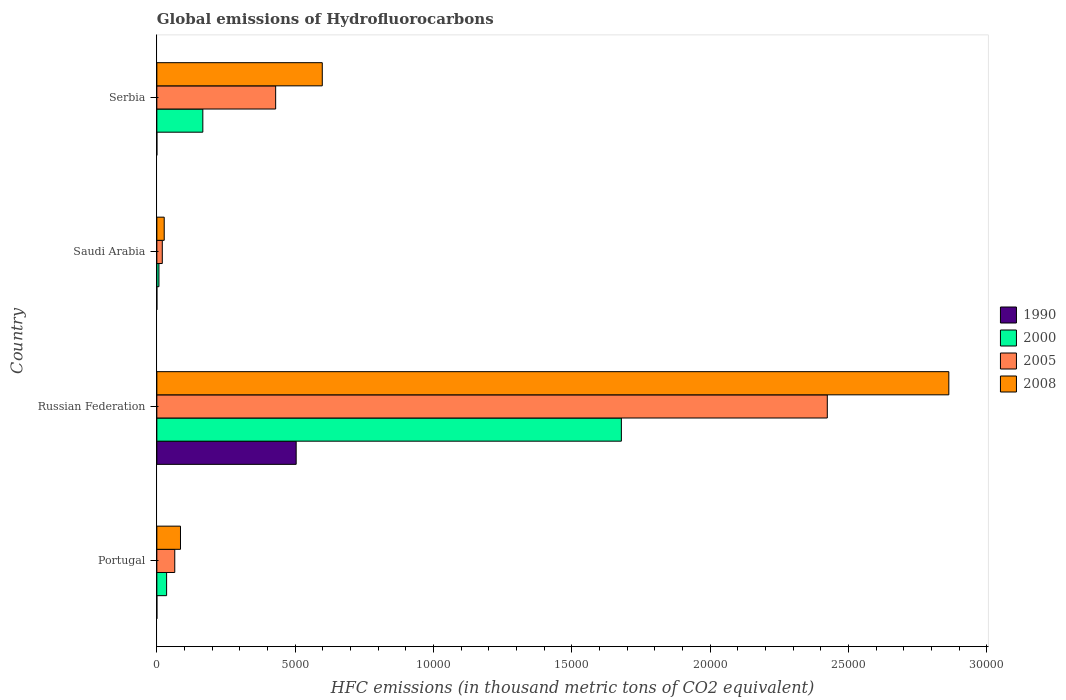Are the number of bars per tick equal to the number of legend labels?
Make the answer very short. Yes. What is the label of the 4th group of bars from the top?
Your answer should be very brief. Portugal. In how many cases, is the number of bars for a given country not equal to the number of legend labels?
Ensure brevity in your answer.  0. What is the global emissions of Hydrofluorocarbons in 2008 in Serbia?
Your answer should be very brief. 5979. Across all countries, what is the maximum global emissions of Hydrofluorocarbons in 1990?
Offer a very short reply. 5035.6. In which country was the global emissions of Hydrofluorocarbons in 2008 maximum?
Your answer should be very brief. Russian Federation. In which country was the global emissions of Hydrofluorocarbons in 2008 minimum?
Ensure brevity in your answer.  Saudi Arabia. What is the total global emissions of Hydrofluorocarbons in 2000 in the graph?
Keep it short and to the point. 1.89e+04. What is the difference between the global emissions of Hydrofluorocarbons in 1990 in Portugal and that in Russian Federation?
Your answer should be compact. -5035.4. What is the difference between the global emissions of Hydrofluorocarbons in 2005 in Russian Federation and the global emissions of Hydrofluorocarbons in 2008 in Portugal?
Provide a succinct answer. 2.34e+04. What is the average global emissions of Hydrofluorocarbons in 1990 per country?
Your answer should be compact. 1259.1. What is the difference between the global emissions of Hydrofluorocarbons in 2008 and global emissions of Hydrofluorocarbons in 1990 in Saudi Arabia?
Your response must be concise. 266.4. In how many countries, is the global emissions of Hydrofluorocarbons in 2000 greater than 4000 thousand metric tons?
Your answer should be compact. 1. What is the ratio of the global emissions of Hydrofluorocarbons in 2000 in Russian Federation to that in Serbia?
Offer a very short reply. 10.1. Is the global emissions of Hydrofluorocarbons in 2000 in Portugal less than that in Saudi Arabia?
Offer a terse response. No. What is the difference between the highest and the second highest global emissions of Hydrofluorocarbons in 2008?
Your response must be concise. 2.26e+04. What is the difference between the highest and the lowest global emissions of Hydrofluorocarbons in 2005?
Provide a succinct answer. 2.40e+04. In how many countries, is the global emissions of Hydrofluorocarbons in 1990 greater than the average global emissions of Hydrofluorocarbons in 1990 taken over all countries?
Provide a succinct answer. 1. What does the 3rd bar from the top in Russian Federation represents?
Your answer should be very brief. 2000. How many bars are there?
Your response must be concise. 16. Are all the bars in the graph horizontal?
Keep it short and to the point. Yes. Are the values on the major ticks of X-axis written in scientific E-notation?
Offer a very short reply. No. Does the graph contain grids?
Your answer should be compact. No. How many legend labels are there?
Offer a very short reply. 4. How are the legend labels stacked?
Ensure brevity in your answer.  Vertical. What is the title of the graph?
Your answer should be compact. Global emissions of Hydrofluorocarbons. What is the label or title of the X-axis?
Your response must be concise. HFC emissions (in thousand metric tons of CO2 equivalent). What is the label or title of the Y-axis?
Give a very brief answer. Country. What is the HFC emissions (in thousand metric tons of CO2 equivalent) of 2000 in Portugal?
Ensure brevity in your answer.  352.7. What is the HFC emissions (in thousand metric tons of CO2 equivalent) in 2005 in Portugal?
Your response must be concise. 647.7. What is the HFC emissions (in thousand metric tons of CO2 equivalent) of 2008 in Portugal?
Offer a terse response. 854.4. What is the HFC emissions (in thousand metric tons of CO2 equivalent) of 1990 in Russian Federation?
Offer a terse response. 5035.6. What is the HFC emissions (in thousand metric tons of CO2 equivalent) in 2000 in Russian Federation?
Your response must be concise. 1.68e+04. What is the HFC emissions (in thousand metric tons of CO2 equivalent) in 2005 in Russian Federation?
Offer a terse response. 2.42e+04. What is the HFC emissions (in thousand metric tons of CO2 equivalent) of 2008 in Russian Federation?
Offer a very short reply. 2.86e+04. What is the HFC emissions (in thousand metric tons of CO2 equivalent) of 2000 in Saudi Arabia?
Offer a terse response. 75.5. What is the HFC emissions (in thousand metric tons of CO2 equivalent) in 2005 in Saudi Arabia?
Make the answer very short. 196.9. What is the HFC emissions (in thousand metric tons of CO2 equivalent) in 2008 in Saudi Arabia?
Your answer should be very brief. 266.5. What is the HFC emissions (in thousand metric tons of CO2 equivalent) of 1990 in Serbia?
Provide a succinct answer. 0.5. What is the HFC emissions (in thousand metric tons of CO2 equivalent) of 2000 in Serbia?
Provide a short and direct response. 1662. What is the HFC emissions (in thousand metric tons of CO2 equivalent) of 2005 in Serbia?
Provide a succinct answer. 4293.8. What is the HFC emissions (in thousand metric tons of CO2 equivalent) in 2008 in Serbia?
Provide a short and direct response. 5979. Across all countries, what is the maximum HFC emissions (in thousand metric tons of CO2 equivalent) in 1990?
Your answer should be compact. 5035.6. Across all countries, what is the maximum HFC emissions (in thousand metric tons of CO2 equivalent) of 2000?
Ensure brevity in your answer.  1.68e+04. Across all countries, what is the maximum HFC emissions (in thousand metric tons of CO2 equivalent) in 2005?
Keep it short and to the point. 2.42e+04. Across all countries, what is the maximum HFC emissions (in thousand metric tons of CO2 equivalent) in 2008?
Provide a succinct answer. 2.86e+04. Across all countries, what is the minimum HFC emissions (in thousand metric tons of CO2 equivalent) in 2000?
Your response must be concise. 75.5. Across all countries, what is the minimum HFC emissions (in thousand metric tons of CO2 equivalent) in 2005?
Provide a succinct answer. 196.9. Across all countries, what is the minimum HFC emissions (in thousand metric tons of CO2 equivalent) in 2008?
Make the answer very short. 266.5. What is the total HFC emissions (in thousand metric tons of CO2 equivalent) in 1990 in the graph?
Provide a short and direct response. 5036.4. What is the total HFC emissions (in thousand metric tons of CO2 equivalent) of 2000 in the graph?
Ensure brevity in your answer.  1.89e+04. What is the total HFC emissions (in thousand metric tons of CO2 equivalent) in 2005 in the graph?
Give a very brief answer. 2.94e+04. What is the total HFC emissions (in thousand metric tons of CO2 equivalent) in 2008 in the graph?
Offer a terse response. 3.57e+04. What is the difference between the HFC emissions (in thousand metric tons of CO2 equivalent) in 1990 in Portugal and that in Russian Federation?
Provide a short and direct response. -5035.4. What is the difference between the HFC emissions (in thousand metric tons of CO2 equivalent) of 2000 in Portugal and that in Russian Federation?
Provide a succinct answer. -1.64e+04. What is the difference between the HFC emissions (in thousand metric tons of CO2 equivalent) of 2005 in Portugal and that in Russian Federation?
Keep it short and to the point. -2.36e+04. What is the difference between the HFC emissions (in thousand metric tons of CO2 equivalent) in 2008 in Portugal and that in Russian Federation?
Your answer should be very brief. -2.78e+04. What is the difference between the HFC emissions (in thousand metric tons of CO2 equivalent) in 2000 in Portugal and that in Saudi Arabia?
Keep it short and to the point. 277.2. What is the difference between the HFC emissions (in thousand metric tons of CO2 equivalent) in 2005 in Portugal and that in Saudi Arabia?
Give a very brief answer. 450.8. What is the difference between the HFC emissions (in thousand metric tons of CO2 equivalent) in 2008 in Portugal and that in Saudi Arabia?
Keep it short and to the point. 587.9. What is the difference between the HFC emissions (in thousand metric tons of CO2 equivalent) in 2000 in Portugal and that in Serbia?
Make the answer very short. -1309.3. What is the difference between the HFC emissions (in thousand metric tons of CO2 equivalent) in 2005 in Portugal and that in Serbia?
Ensure brevity in your answer.  -3646.1. What is the difference between the HFC emissions (in thousand metric tons of CO2 equivalent) of 2008 in Portugal and that in Serbia?
Provide a short and direct response. -5124.6. What is the difference between the HFC emissions (in thousand metric tons of CO2 equivalent) of 1990 in Russian Federation and that in Saudi Arabia?
Your answer should be compact. 5035.5. What is the difference between the HFC emissions (in thousand metric tons of CO2 equivalent) of 2000 in Russian Federation and that in Saudi Arabia?
Give a very brief answer. 1.67e+04. What is the difference between the HFC emissions (in thousand metric tons of CO2 equivalent) of 2005 in Russian Federation and that in Saudi Arabia?
Give a very brief answer. 2.40e+04. What is the difference between the HFC emissions (in thousand metric tons of CO2 equivalent) of 2008 in Russian Federation and that in Saudi Arabia?
Provide a short and direct response. 2.84e+04. What is the difference between the HFC emissions (in thousand metric tons of CO2 equivalent) of 1990 in Russian Federation and that in Serbia?
Ensure brevity in your answer.  5035.1. What is the difference between the HFC emissions (in thousand metric tons of CO2 equivalent) of 2000 in Russian Federation and that in Serbia?
Offer a terse response. 1.51e+04. What is the difference between the HFC emissions (in thousand metric tons of CO2 equivalent) in 2005 in Russian Federation and that in Serbia?
Make the answer very short. 1.99e+04. What is the difference between the HFC emissions (in thousand metric tons of CO2 equivalent) in 2008 in Russian Federation and that in Serbia?
Your answer should be compact. 2.26e+04. What is the difference between the HFC emissions (in thousand metric tons of CO2 equivalent) in 1990 in Saudi Arabia and that in Serbia?
Offer a very short reply. -0.4. What is the difference between the HFC emissions (in thousand metric tons of CO2 equivalent) of 2000 in Saudi Arabia and that in Serbia?
Offer a very short reply. -1586.5. What is the difference between the HFC emissions (in thousand metric tons of CO2 equivalent) in 2005 in Saudi Arabia and that in Serbia?
Your answer should be compact. -4096.9. What is the difference between the HFC emissions (in thousand metric tons of CO2 equivalent) in 2008 in Saudi Arabia and that in Serbia?
Keep it short and to the point. -5712.5. What is the difference between the HFC emissions (in thousand metric tons of CO2 equivalent) in 1990 in Portugal and the HFC emissions (in thousand metric tons of CO2 equivalent) in 2000 in Russian Federation?
Offer a very short reply. -1.68e+04. What is the difference between the HFC emissions (in thousand metric tons of CO2 equivalent) of 1990 in Portugal and the HFC emissions (in thousand metric tons of CO2 equivalent) of 2005 in Russian Federation?
Provide a succinct answer. -2.42e+04. What is the difference between the HFC emissions (in thousand metric tons of CO2 equivalent) of 1990 in Portugal and the HFC emissions (in thousand metric tons of CO2 equivalent) of 2008 in Russian Federation?
Your answer should be compact. -2.86e+04. What is the difference between the HFC emissions (in thousand metric tons of CO2 equivalent) of 2000 in Portugal and the HFC emissions (in thousand metric tons of CO2 equivalent) of 2005 in Russian Federation?
Offer a terse response. -2.39e+04. What is the difference between the HFC emissions (in thousand metric tons of CO2 equivalent) in 2000 in Portugal and the HFC emissions (in thousand metric tons of CO2 equivalent) in 2008 in Russian Federation?
Your answer should be very brief. -2.83e+04. What is the difference between the HFC emissions (in thousand metric tons of CO2 equivalent) in 2005 in Portugal and the HFC emissions (in thousand metric tons of CO2 equivalent) in 2008 in Russian Federation?
Ensure brevity in your answer.  -2.80e+04. What is the difference between the HFC emissions (in thousand metric tons of CO2 equivalent) of 1990 in Portugal and the HFC emissions (in thousand metric tons of CO2 equivalent) of 2000 in Saudi Arabia?
Give a very brief answer. -75.3. What is the difference between the HFC emissions (in thousand metric tons of CO2 equivalent) of 1990 in Portugal and the HFC emissions (in thousand metric tons of CO2 equivalent) of 2005 in Saudi Arabia?
Provide a succinct answer. -196.7. What is the difference between the HFC emissions (in thousand metric tons of CO2 equivalent) of 1990 in Portugal and the HFC emissions (in thousand metric tons of CO2 equivalent) of 2008 in Saudi Arabia?
Offer a very short reply. -266.3. What is the difference between the HFC emissions (in thousand metric tons of CO2 equivalent) in 2000 in Portugal and the HFC emissions (in thousand metric tons of CO2 equivalent) in 2005 in Saudi Arabia?
Provide a succinct answer. 155.8. What is the difference between the HFC emissions (in thousand metric tons of CO2 equivalent) in 2000 in Portugal and the HFC emissions (in thousand metric tons of CO2 equivalent) in 2008 in Saudi Arabia?
Ensure brevity in your answer.  86.2. What is the difference between the HFC emissions (in thousand metric tons of CO2 equivalent) of 2005 in Portugal and the HFC emissions (in thousand metric tons of CO2 equivalent) of 2008 in Saudi Arabia?
Your answer should be compact. 381.2. What is the difference between the HFC emissions (in thousand metric tons of CO2 equivalent) of 1990 in Portugal and the HFC emissions (in thousand metric tons of CO2 equivalent) of 2000 in Serbia?
Your answer should be compact. -1661.8. What is the difference between the HFC emissions (in thousand metric tons of CO2 equivalent) of 1990 in Portugal and the HFC emissions (in thousand metric tons of CO2 equivalent) of 2005 in Serbia?
Keep it short and to the point. -4293.6. What is the difference between the HFC emissions (in thousand metric tons of CO2 equivalent) of 1990 in Portugal and the HFC emissions (in thousand metric tons of CO2 equivalent) of 2008 in Serbia?
Your answer should be very brief. -5978.8. What is the difference between the HFC emissions (in thousand metric tons of CO2 equivalent) of 2000 in Portugal and the HFC emissions (in thousand metric tons of CO2 equivalent) of 2005 in Serbia?
Your response must be concise. -3941.1. What is the difference between the HFC emissions (in thousand metric tons of CO2 equivalent) in 2000 in Portugal and the HFC emissions (in thousand metric tons of CO2 equivalent) in 2008 in Serbia?
Give a very brief answer. -5626.3. What is the difference between the HFC emissions (in thousand metric tons of CO2 equivalent) of 2005 in Portugal and the HFC emissions (in thousand metric tons of CO2 equivalent) of 2008 in Serbia?
Ensure brevity in your answer.  -5331.3. What is the difference between the HFC emissions (in thousand metric tons of CO2 equivalent) of 1990 in Russian Federation and the HFC emissions (in thousand metric tons of CO2 equivalent) of 2000 in Saudi Arabia?
Your response must be concise. 4960.1. What is the difference between the HFC emissions (in thousand metric tons of CO2 equivalent) of 1990 in Russian Federation and the HFC emissions (in thousand metric tons of CO2 equivalent) of 2005 in Saudi Arabia?
Your response must be concise. 4838.7. What is the difference between the HFC emissions (in thousand metric tons of CO2 equivalent) of 1990 in Russian Federation and the HFC emissions (in thousand metric tons of CO2 equivalent) of 2008 in Saudi Arabia?
Give a very brief answer. 4769.1. What is the difference between the HFC emissions (in thousand metric tons of CO2 equivalent) in 2000 in Russian Federation and the HFC emissions (in thousand metric tons of CO2 equivalent) in 2005 in Saudi Arabia?
Your answer should be very brief. 1.66e+04. What is the difference between the HFC emissions (in thousand metric tons of CO2 equivalent) in 2000 in Russian Federation and the HFC emissions (in thousand metric tons of CO2 equivalent) in 2008 in Saudi Arabia?
Offer a terse response. 1.65e+04. What is the difference between the HFC emissions (in thousand metric tons of CO2 equivalent) in 2005 in Russian Federation and the HFC emissions (in thousand metric tons of CO2 equivalent) in 2008 in Saudi Arabia?
Your response must be concise. 2.40e+04. What is the difference between the HFC emissions (in thousand metric tons of CO2 equivalent) in 1990 in Russian Federation and the HFC emissions (in thousand metric tons of CO2 equivalent) in 2000 in Serbia?
Your response must be concise. 3373.6. What is the difference between the HFC emissions (in thousand metric tons of CO2 equivalent) in 1990 in Russian Federation and the HFC emissions (in thousand metric tons of CO2 equivalent) in 2005 in Serbia?
Offer a terse response. 741.8. What is the difference between the HFC emissions (in thousand metric tons of CO2 equivalent) of 1990 in Russian Federation and the HFC emissions (in thousand metric tons of CO2 equivalent) of 2008 in Serbia?
Give a very brief answer. -943.4. What is the difference between the HFC emissions (in thousand metric tons of CO2 equivalent) of 2000 in Russian Federation and the HFC emissions (in thousand metric tons of CO2 equivalent) of 2005 in Serbia?
Offer a very short reply. 1.25e+04. What is the difference between the HFC emissions (in thousand metric tons of CO2 equivalent) of 2000 in Russian Federation and the HFC emissions (in thousand metric tons of CO2 equivalent) of 2008 in Serbia?
Keep it short and to the point. 1.08e+04. What is the difference between the HFC emissions (in thousand metric tons of CO2 equivalent) of 2005 in Russian Federation and the HFC emissions (in thousand metric tons of CO2 equivalent) of 2008 in Serbia?
Offer a very short reply. 1.83e+04. What is the difference between the HFC emissions (in thousand metric tons of CO2 equivalent) of 1990 in Saudi Arabia and the HFC emissions (in thousand metric tons of CO2 equivalent) of 2000 in Serbia?
Give a very brief answer. -1661.9. What is the difference between the HFC emissions (in thousand metric tons of CO2 equivalent) of 1990 in Saudi Arabia and the HFC emissions (in thousand metric tons of CO2 equivalent) of 2005 in Serbia?
Keep it short and to the point. -4293.7. What is the difference between the HFC emissions (in thousand metric tons of CO2 equivalent) of 1990 in Saudi Arabia and the HFC emissions (in thousand metric tons of CO2 equivalent) of 2008 in Serbia?
Make the answer very short. -5978.9. What is the difference between the HFC emissions (in thousand metric tons of CO2 equivalent) in 2000 in Saudi Arabia and the HFC emissions (in thousand metric tons of CO2 equivalent) in 2005 in Serbia?
Your answer should be very brief. -4218.3. What is the difference between the HFC emissions (in thousand metric tons of CO2 equivalent) of 2000 in Saudi Arabia and the HFC emissions (in thousand metric tons of CO2 equivalent) of 2008 in Serbia?
Give a very brief answer. -5903.5. What is the difference between the HFC emissions (in thousand metric tons of CO2 equivalent) of 2005 in Saudi Arabia and the HFC emissions (in thousand metric tons of CO2 equivalent) of 2008 in Serbia?
Your answer should be very brief. -5782.1. What is the average HFC emissions (in thousand metric tons of CO2 equivalent) in 1990 per country?
Give a very brief answer. 1259.1. What is the average HFC emissions (in thousand metric tons of CO2 equivalent) of 2000 per country?
Make the answer very short. 4719.73. What is the average HFC emissions (in thousand metric tons of CO2 equivalent) in 2005 per country?
Ensure brevity in your answer.  7342.43. What is the average HFC emissions (in thousand metric tons of CO2 equivalent) in 2008 per country?
Offer a terse response. 8930.85. What is the difference between the HFC emissions (in thousand metric tons of CO2 equivalent) of 1990 and HFC emissions (in thousand metric tons of CO2 equivalent) of 2000 in Portugal?
Ensure brevity in your answer.  -352.5. What is the difference between the HFC emissions (in thousand metric tons of CO2 equivalent) in 1990 and HFC emissions (in thousand metric tons of CO2 equivalent) in 2005 in Portugal?
Your answer should be compact. -647.5. What is the difference between the HFC emissions (in thousand metric tons of CO2 equivalent) in 1990 and HFC emissions (in thousand metric tons of CO2 equivalent) in 2008 in Portugal?
Your answer should be very brief. -854.2. What is the difference between the HFC emissions (in thousand metric tons of CO2 equivalent) in 2000 and HFC emissions (in thousand metric tons of CO2 equivalent) in 2005 in Portugal?
Your answer should be compact. -295. What is the difference between the HFC emissions (in thousand metric tons of CO2 equivalent) in 2000 and HFC emissions (in thousand metric tons of CO2 equivalent) in 2008 in Portugal?
Offer a terse response. -501.7. What is the difference between the HFC emissions (in thousand metric tons of CO2 equivalent) of 2005 and HFC emissions (in thousand metric tons of CO2 equivalent) of 2008 in Portugal?
Provide a short and direct response. -206.7. What is the difference between the HFC emissions (in thousand metric tons of CO2 equivalent) in 1990 and HFC emissions (in thousand metric tons of CO2 equivalent) in 2000 in Russian Federation?
Provide a short and direct response. -1.18e+04. What is the difference between the HFC emissions (in thousand metric tons of CO2 equivalent) in 1990 and HFC emissions (in thousand metric tons of CO2 equivalent) in 2005 in Russian Federation?
Make the answer very short. -1.92e+04. What is the difference between the HFC emissions (in thousand metric tons of CO2 equivalent) in 1990 and HFC emissions (in thousand metric tons of CO2 equivalent) in 2008 in Russian Federation?
Give a very brief answer. -2.36e+04. What is the difference between the HFC emissions (in thousand metric tons of CO2 equivalent) of 2000 and HFC emissions (in thousand metric tons of CO2 equivalent) of 2005 in Russian Federation?
Ensure brevity in your answer.  -7442.6. What is the difference between the HFC emissions (in thousand metric tons of CO2 equivalent) in 2000 and HFC emissions (in thousand metric tons of CO2 equivalent) in 2008 in Russian Federation?
Make the answer very short. -1.18e+04. What is the difference between the HFC emissions (in thousand metric tons of CO2 equivalent) of 2005 and HFC emissions (in thousand metric tons of CO2 equivalent) of 2008 in Russian Federation?
Make the answer very short. -4392.2. What is the difference between the HFC emissions (in thousand metric tons of CO2 equivalent) of 1990 and HFC emissions (in thousand metric tons of CO2 equivalent) of 2000 in Saudi Arabia?
Make the answer very short. -75.4. What is the difference between the HFC emissions (in thousand metric tons of CO2 equivalent) in 1990 and HFC emissions (in thousand metric tons of CO2 equivalent) in 2005 in Saudi Arabia?
Your answer should be very brief. -196.8. What is the difference between the HFC emissions (in thousand metric tons of CO2 equivalent) of 1990 and HFC emissions (in thousand metric tons of CO2 equivalent) of 2008 in Saudi Arabia?
Give a very brief answer. -266.4. What is the difference between the HFC emissions (in thousand metric tons of CO2 equivalent) of 2000 and HFC emissions (in thousand metric tons of CO2 equivalent) of 2005 in Saudi Arabia?
Make the answer very short. -121.4. What is the difference between the HFC emissions (in thousand metric tons of CO2 equivalent) in 2000 and HFC emissions (in thousand metric tons of CO2 equivalent) in 2008 in Saudi Arabia?
Make the answer very short. -191. What is the difference between the HFC emissions (in thousand metric tons of CO2 equivalent) of 2005 and HFC emissions (in thousand metric tons of CO2 equivalent) of 2008 in Saudi Arabia?
Provide a succinct answer. -69.6. What is the difference between the HFC emissions (in thousand metric tons of CO2 equivalent) of 1990 and HFC emissions (in thousand metric tons of CO2 equivalent) of 2000 in Serbia?
Provide a short and direct response. -1661.5. What is the difference between the HFC emissions (in thousand metric tons of CO2 equivalent) of 1990 and HFC emissions (in thousand metric tons of CO2 equivalent) of 2005 in Serbia?
Give a very brief answer. -4293.3. What is the difference between the HFC emissions (in thousand metric tons of CO2 equivalent) in 1990 and HFC emissions (in thousand metric tons of CO2 equivalent) in 2008 in Serbia?
Your response must be concise. -5978.5. What is the difference between the HFC emissions (in thousand metric tons of CO2 equivalent) in 2000 and HFC emissions (in thousand metric tons of CO2 equivalent) in 2005 in Serbia?
Provide a succinct answer. -2631.8. What is the difference between the HFC emissions (in thousand metric tons of CO2 equivalent) of 2000 and HFC emissions (in thousand metric tons of CO2 equivalent) of 2008 in Serbia?
Your response must be concise. -4317. What is the difference between the HFC emissions (in thousand metric tons of CO2 equivalent) of 2005 and HFC emissions (in thousand metric tons of CO2 equivalent) of 2008 in Serbia?
Offer a terse response. -1685.2. What is the ratio of the HFC emissions (in thousand metric tons of CO2 equivalent) of 1990 in Portugal to that in Russian Federation?
Your response must be concise. 0. What is the ratio of the HFC emissions (in thousand metric tons of CO2 equivalent) of 2000 in Portugal to that in Russian Federation?
Give a very brief answer. 0.02. What is the ratio of the HFC emissions (in thousand metric tons of CO2 equivalent) of 2005 in Portugal to that in Russian Federation?
Your answer should be compact. 0.03. What is the ratio of the HFC emissions (in thousand metric tons of CO2 equivalent) in 2008 in Portugal to that in Russian Federation?
Provide a short and direct response. 0.03. What is the ratio of the HFC emissions (in thousand metric tons of CO2 equivalent) of 2000 in Portugal to that in Saudi Arabia?
Keep it short and to the point. 4.67. What is the ratio of the HFC emissions (in thousand metric tons of CO2 equivalent) of 2005 in Portugal to that in Saudi Arabia?
Offer a terse response. 3.29. What is the ratio of the HFC emissions (in thousand metric tons of CO2 equivalent) of 2008 in Portugal to that in Saudi Arabia?
Offer a terse response. 3.21. What is the ratio of the HFC emissions (in thousand metric tons of CO2 equivalent) in 1990 in Portugal to that in Serbia?
Your answer should be very brief. 0.4. What is the ratio of the HFC emissions (in thousand metric tons of CO2 equivalent) in 2000 in Portugal to that in Serbia?
Your answer should be compact. 0.21. What is the ratio of the HFC emissions (in thousand metric tons of CO2 equivalent) of 2005 in Portugal to that in Serbia?
Keep it short and to the point. 0.15. What is the ratio of the HFC emissions (in thousand metric tons of CO2 equivalent) in 2008 in Portugal to that in Serbia?
Your answer should be very brief. 0.14. What is the ratio of the HFC emissions (in thousand metric tons of CO2 equivalent) in 1990 in Russian Federation to that in Saudi Arabia?
Provide a short and direct response. 5.04e+04. What is the ratio of the HFC emissions (in thousand metric tons of CO2 equivalent) of 2000 in Russian Federation to that in Saudi Arabia?
Offer a terse response. 222.37. What is the ratio of the HFC emissions (in thousand metric tons of CO2 equivalent) of 2005 in Russian Federation to that in Saudi Arabia?
Your answer should be compact. 123.06. What is the ratio of the HFC emissions (in thousand metric tons of CO2 equivalent) in 2008 in Russian Federation to that in Saudi Arabia?
Keep it short and to the point. 107.41. What is the ratio of the HFC emissions (in thousand metric tons of CO2 equivalent) of 1990 in Russian Federation to that in Serbia?
Provide a succinct answer. 1.01e+04. What is the ratio of the HFC emissions (in thousand metric tons of CO2 equivalent) of 2000 in Russian Federation to that in Serbia?
Your response must be concise. 10.1. What is the ratio of the HFC emissions (in thousand metric tons of CO2 equivalent) of 2005 in Russian Federation to that in Serbia?
Provide a short and direct response. 5.64. What is the ratio of the HFC emissions (in thousand metric tons of CO2 equivalent) of 2008 in Russian Federation to that in Serbia?
Provide a succinct answer. 4.79. What is the ratio of the HFC emissions (in thousand metric tons of CO2 equivalent) in 1990 in Saudi Arabia to that in Serbia?
Ensure brevity in your answer.  0.2. What is the ratio of the HFC emissions (in thousand metric tons of CO2 equivalent) of 2000 in Saudi Arabia to that in Serbia?
Keep it short and to the point. 0.05. What is the ratio of the HFC emissions (in thousand metric tons of CO2 equivalent) in 2005 in Saudi Arabia to that in Serbia?
Make the answer very short. 0.05. What is the ratio of the HFC emissions (in thousand metric tons of CO2 equivalent) in 2008 in Saudi Arabia to that in Serbia?
Provide a short and direct response. 0.04. What is the difference between the highest and the second highest HFC emissions (in thousand metric tons of CO2 equivalent) of 1990?
Your answer should be very brief. 5035.1. What is the difference between the highest and the second highest HFC emissions (in thousand metric tons of CO2 equivalent) in 2000?
Provide a succinct answer. 1.51e+04. What is the difference between the highest and the second highest HFC emissions (in thousand metric tons of CO2 equivalent) in 2005?
Ensure brevity in your answer.  1.99e+04. What is the difference between the highest and the second highest HFC emissions (in thousand metric tons of CO2 equivalent) in 2008?
Your response must be concise. 2.26e+04. What is the difference between the highest and the lowest HFC emissions (in thousand metric tons of CO2 equivalent) of 1990?
Give a very brief answer. 5035.5. What is the difference between the highest and the lowest HFC emissions (in thousand metric tons of CO2 equivalent) in 2000?
Your answer should be compact. 1.67e+04. What is the difference between the highest and the lowest HFC emissions (in thousand metric tons of CO2 equivalent) in 2005?
Offer a very short reply. 2.40e+04. What is the difference between the highest and the lowest HFC emissions (in thousand metric tons of CO2 equivalent) of 2008?
Provide a succinct answer. 2.84e+04. 